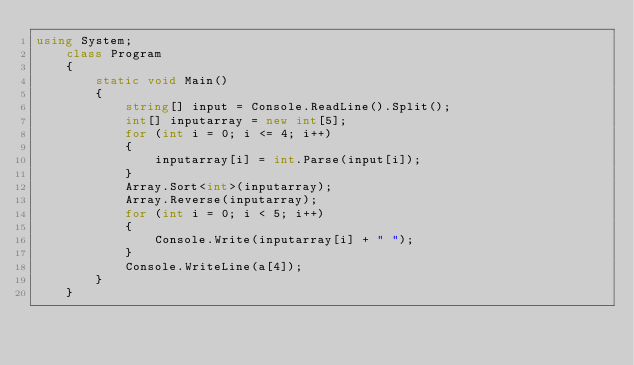<code> <loc_0><loc_0><loc_500><loc_500><_C#_>using System;
    class Program
    {
        static void Main()
        {
            string[] input = Console.ReadLine().Split();
            int[] inputarray = new int[5];
            for (int i = 0; i <= 4; i++)
            {
                inputarray[i] = int.Parse(input[i]);
            }
            Array.Sort<int>(inputarray);
            Array.Reverse(inputarray);
            for (int i = 0; i < 5; i++)
            {
                Console.Write(inputarray[i] + " ");
            }
            Console.WriteLine(a[4]);
        }
    }</code> 